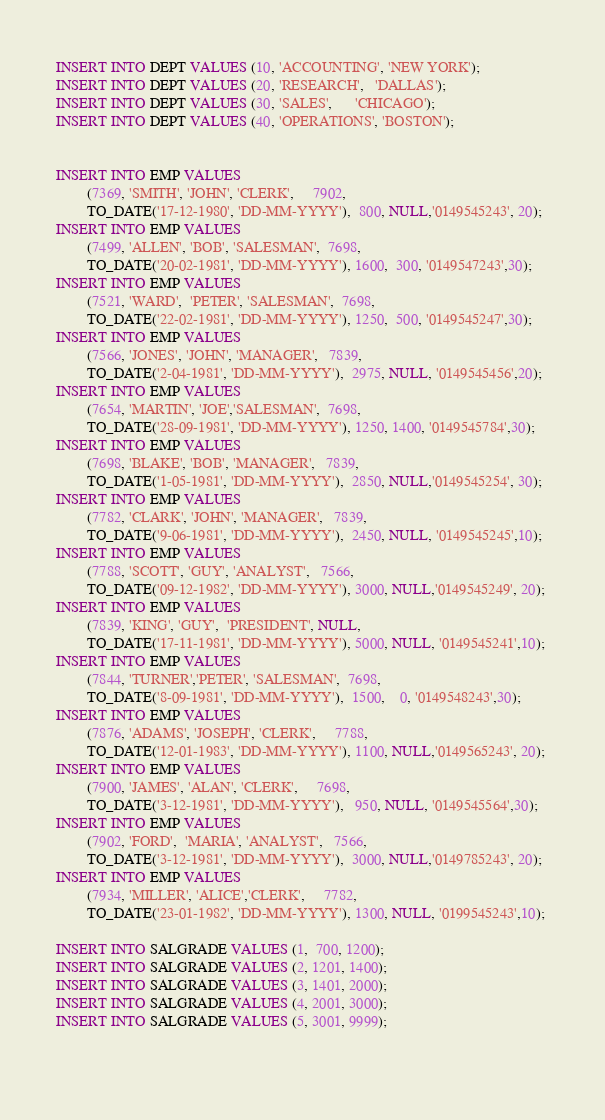<code> <loc_0><loc_0><loc_500><loc_500><_SQL_>INSERT INTO DEPT VALUES (10, 'ACCOUNTING', 'NEW YORK');
INSERT INTO DEPT VALUES (20, 'RESEARCH',   'DALLAS');
INSERT INTO DEPT VALUES (30, 'SALES',      'CHICAGO');
INSERT INTO DEPT VALUES (40, 'OPERATIONS', 'BOSTON');


INSERT INTO EMP VALUES
        (7369, 'SMITH', 'JOHN', 'CLERK',     7902,
        TO_DATE('17-12-1980', 'DD-MM-YYYY'),  800, NULL,'0149545243', 20);
INSERT INTO EMP VALUES
        (7499, 'ALLEN', 'BOB', 'SALESMAN',  7698,
        TO_DATE('20-02-1981', 'DD-MM-YYYY'), 1600,  300, '0149547243',30);
INSERT INTO EMP VALUES
        (7521, 'WARD',  'PETER', 'SALESMAN',  7698,
        TO_DATE('22-02-1981', 'DD-MM-YYYY'), 1250,  500, '0149545247',30);
INSERT INTO EMP VALUES
        (7566, 'JONES', 'JOHN', 'MANAGER',   7839,
        TO_DATE('2-04-1981', 'DD-MM-YYYY'),  2975, NULL, '0149545456',20);
INSERT INTO EMP VALUES
        (7654, 'MARTIN', 'JOE','SALESMAN',  7698,
        TO_DATE('28-09-1981', 'DD-MM-YYYY'), 1250, 1400, '0149545784',30);
INSERT INTO EMP VALUES
        (7698, 'BLAKE', 'BOB', 'MANAGER',   7839,
        TO_DATE('1-05-1981', 'DD-MM-YYYY'),  2850, NULL,'0149545254', 30);
INSERT INTO EMP VALUES
        (7782, 'CLARK', 'JOHN', 'MANAGER',   7839,
        TO_DATE('9-06-1981', 'DD-MM-YYYY'),  2450, NULL, '0149545245',10);
INSERT INTO EMP VALUES
        (7788, 'SCOTT', 'GUY', 'ANALYST',   7566,
        TO_DATE('09-12-1982', 'DD-MM-YYYY'), 3000, NULL,'0149545249', 20);
INSERT INTO EMP VALUES
        (7839, 'KING', 'GUY',  'PRESIDENT', NULL,
        TO_DATE('17-11-1981', 'DD-MM-YYYY'), 5000, NULL, '0149545241',10);
INSERT INTO EMP VALUES
        (7844, 'TURNER','PETER', 'SALESMAN',  7698,
        TO_DATE('8-09-1981', 'DD-MM-YYYY'),  1500,    0, '0149548243',30);
INSERT INTO EMP VALUES
        (7876, 'ADAMS', 'JOSEPH', 'CLERK',     7788,
        TO_DATE('12-01-1983', 'DD-MM-YYYY'), 1100, NULL,'0149565243', 20);
INSERT INTO EMP VALUES
        (7900, 'JAMES', 'ALAN', 'CLERK',     7698,
        TO_DATE('3-12-1981', 'DD-MM-YYYY'),   950, NULL, '0149545564',30);
INSERT INTO EMP VALUES
        (7902, 'FORD',  'MARIA', 'ANALYST',   7566,
        TO_DATE('3-12-1981', 'DD-MM-YYYY'),  3000, NULL,'0149785243', 20);
INSERT INTO EMP VALUES
        (7934, 'MILLER', 'ALICE','CLERK',     7782,
        TO_DATE('23-01-1982', 'DD-MM-YYYY'), 1300, NULL, '0199545243',10); 

INSERT INTO SALGRADE VALUES (1,  700, 1200);
INSERT INTO SALGRADE VALUES (2, 1201, 1400);
INSERT INTO SALGRADE VALUES (3, 1401, 2000);
INSERT INTO SALGRADE VALUES (4, 2001, 3000);
INSERT INTO SALGRADE VALUES (5, 3001, 9999);

 
</code> 